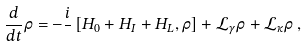Convert formula to latex. <formula><loc_0><loc_0><loc_500><loc_500>\frac { d } { d t } \rho = - \frac { i } { } \left [ H _ { 0 } + H _ { I } + H _ { L } , \rho \right ] + \mathcal { L } _ { \gamma } \rho + \mathcal { L } _ { \kappa } \rho \, ,</formula> 